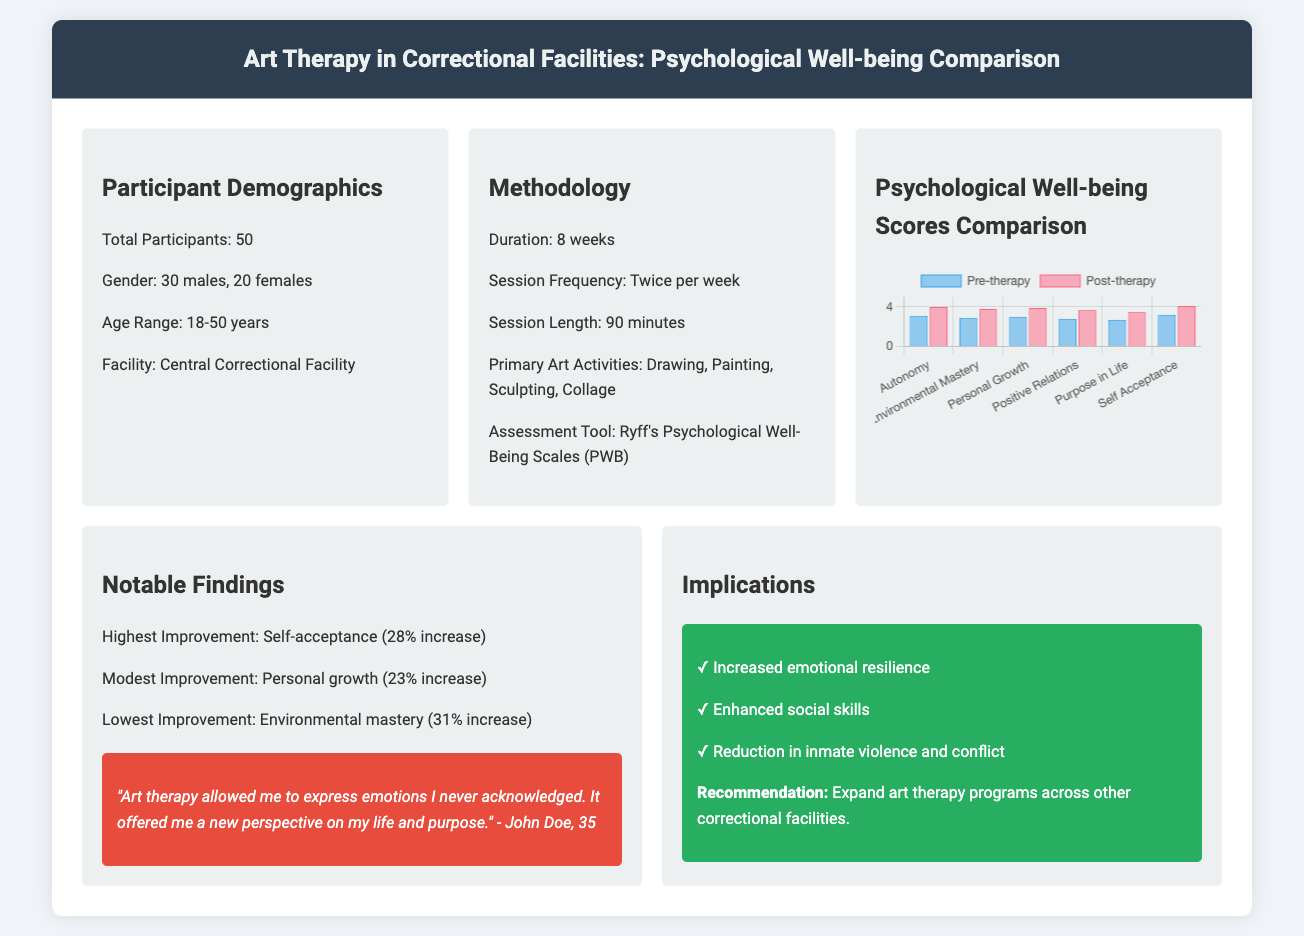what is the total number of participants? The total number of participants is directly stated in the document under the demographics section.
Answer: 50 what is the age range of participants? The age range is specified in the demographics section of the document.
Answer: 18-50 years how many sessions were conducted in total? The total number of sessions can be calculated by the session frequency and duration stated in the methodology section. There are 16 sessions (2 sessions per week for 8 weeks).
Answer: 16 which psychological well-being dimension had the highest improvement? The highest improvement is noted in the notable findings section, referencing a specific dimension of well-being.
Answer: Self-acceptance what tool was used for assessment? The assessment tool is identified in the methodology section of the document.
Answer: Ryff's Psychological Well-Being Scales how much did personal growth improve by? The increase in personal growth is specified in the notable findings section.
Answer: 23% increase which group had more participants, males or females? The gender distribution is described in the demographics section, providing the counts for each group.
Answer: Males how long was each art therapy session? The length of each session is mentioned in the methodology section.
Answer: 90 minutes which aspect showed the lowest improvement? The lowest improvement is mentioned in the notable findings section.
Answer: Environmental mastery 